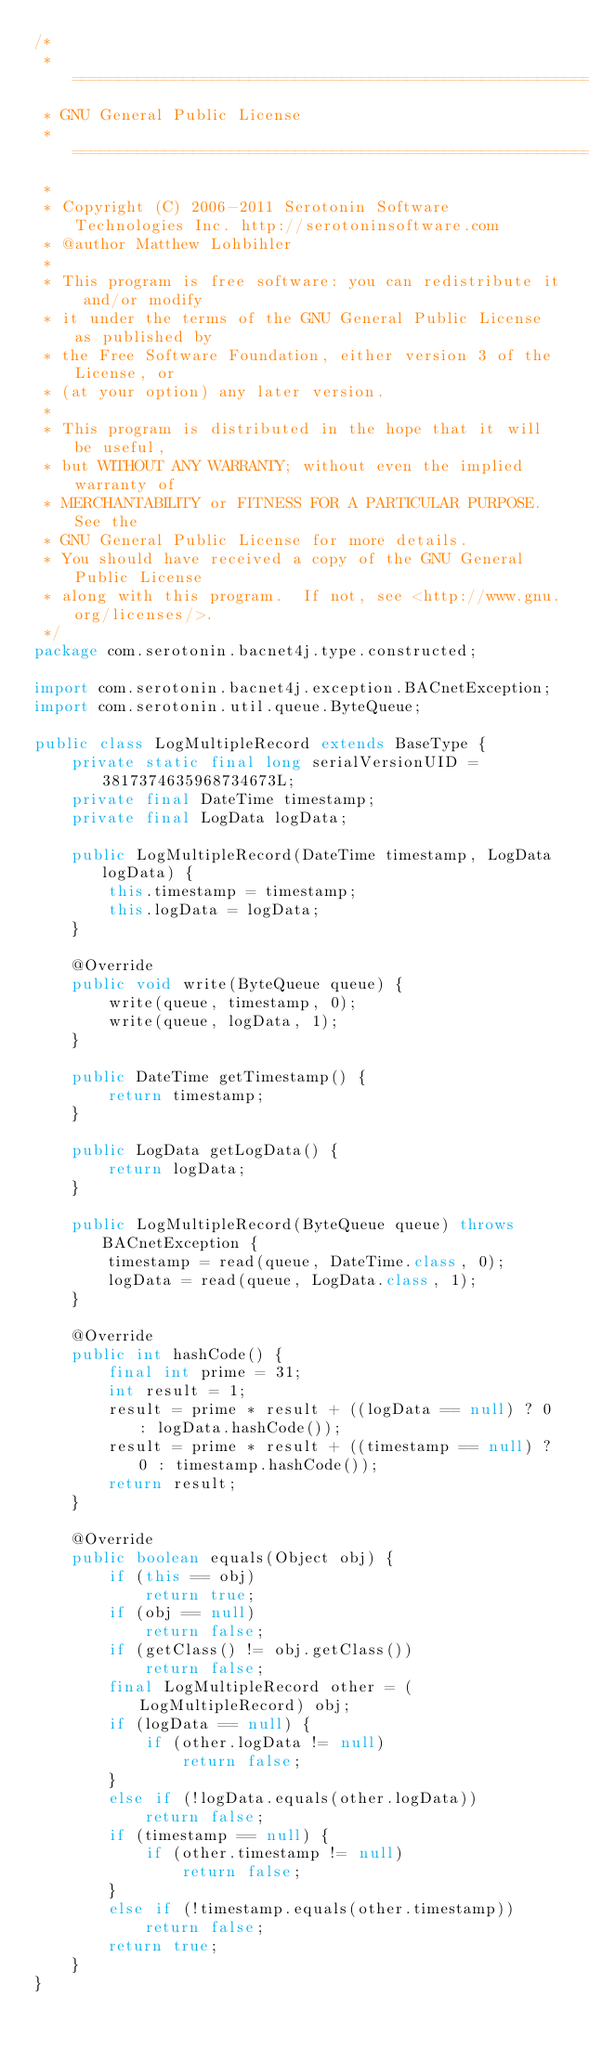Convert code to text. <code><loc_0><loc_0><loc_500><loc_500><_Java_>/*
 * ============================================================================
 * GNU General Public License
 * ============================================================================
 *
 * Copyright (C) 2006-2011 Serotonin Software Technologies Inc. http://serotoninsoftware.com
 * @author Matthew Lohbihler
 * 
 * This program is free software: you can redistribute it and/or modify
 * it under the terms of the GNU General Public License as published by
 * the Free Software Foundation, either version 3 of the License, or
 * (at your option) any later version.
 * 
 * This program is distributed in the hope that it will be useful,
 * but WITHOUT ANY WARRANTY; without even the implied warranty of
 * MERCHANTABILITY or FITNESS FOR A PARTICULAR PURPOSE.  See the
 * GNU General Public License for more details.
 * You should have received a copy of the GNU General Public License
 * along with this program.  If not, see <http://www.gnu.org/licenses/>.
 */
package com.serotonin.bacnet4j.type.constructed;

import com.serotonin.bacnet4j.exception.BACnetException;
import com.serotonin.util.queue.ByteQueue;

public class LogMultipleRecord extends BaseType {
    private static final long serialVersionUID = 3817374635968734673L;
    private final DateTime timestamp;
    private final LogData logData;

    public LogMultipleRecord(DateTime timestamp, LogData logData) {
        this.timestamp = timestamp;
        this.logData = logData;
    }

    @Override
    public void write(ByteQueue queue) {
        write(queue, timestamp, 0);
        write(queue, logData, 1);
    }

    public DateTime getTimestamp() {
        return timestamp;
    }

    public LogData getLogData() {
        return logData;
    }

    public LogMultipleRecord(ByteQueue queue) throws BACnetException {
        timestamp = read(queue, DateTime.class, 0);
        logData = read(queue, LogData.class, 1);
    }

    @Override
    public int hashCode() {
        final int prime = 31;
        int result = 1;
        result = prime * result + ((logData == null) ? 0 : logData.hashCode());
        result = prime * result + ((timestamp == null) ? 0 : timestamp.hashCode());
        return result;
    }

    @Override
    public boolean equals(Object obj) {
        if (this == obj)
            return true;
        if (obj == null)
            return false;
        if (getClass() != obj.getClass())
            return false;
        final LogMultipleRecord other = (LogMultipleRecord) obj;
        if (logData == null) {
            if (other.logData != null)
                return false;
        }
        else if (!logData.equals(other.logData))
            return false;
        if (timestamp == null) {
            if (other.timestamp != null)
                return false;
        }
        else if (!timestamp.equals(other.timestamp))
            return false;
        return true;
    }
}
</code> 